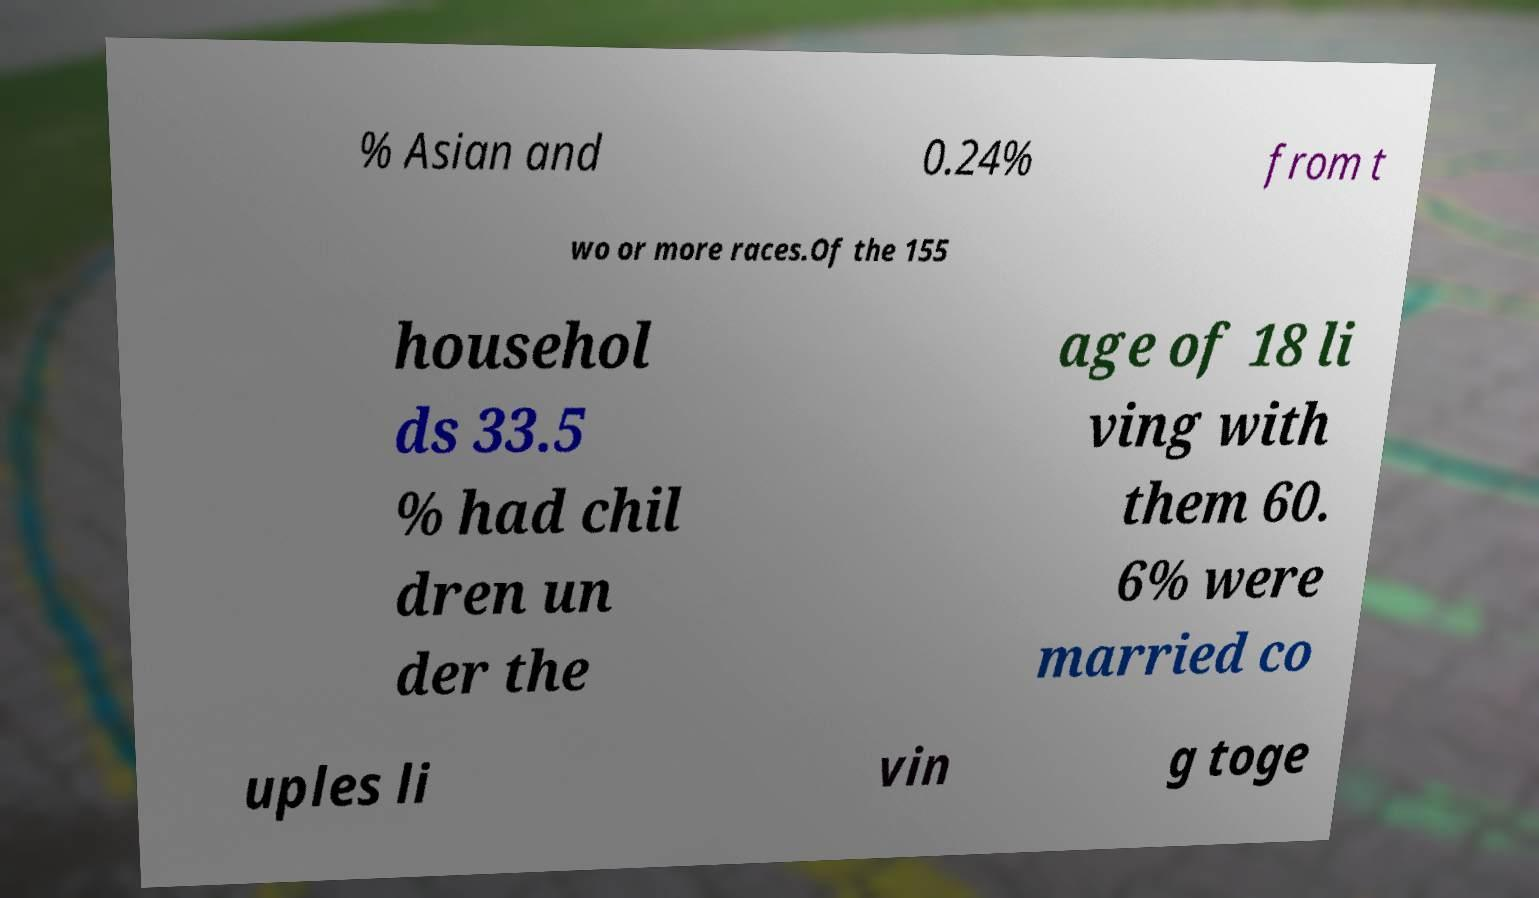Could you assist in decoding the text presented in this image and type it out clearly? % Asian and 0.24% from t wo or more races.Of the 155 househol ds 33.5 % had chil dren un der the age of 18 li ving with them 60. 6% were married co uples li vin g toge 